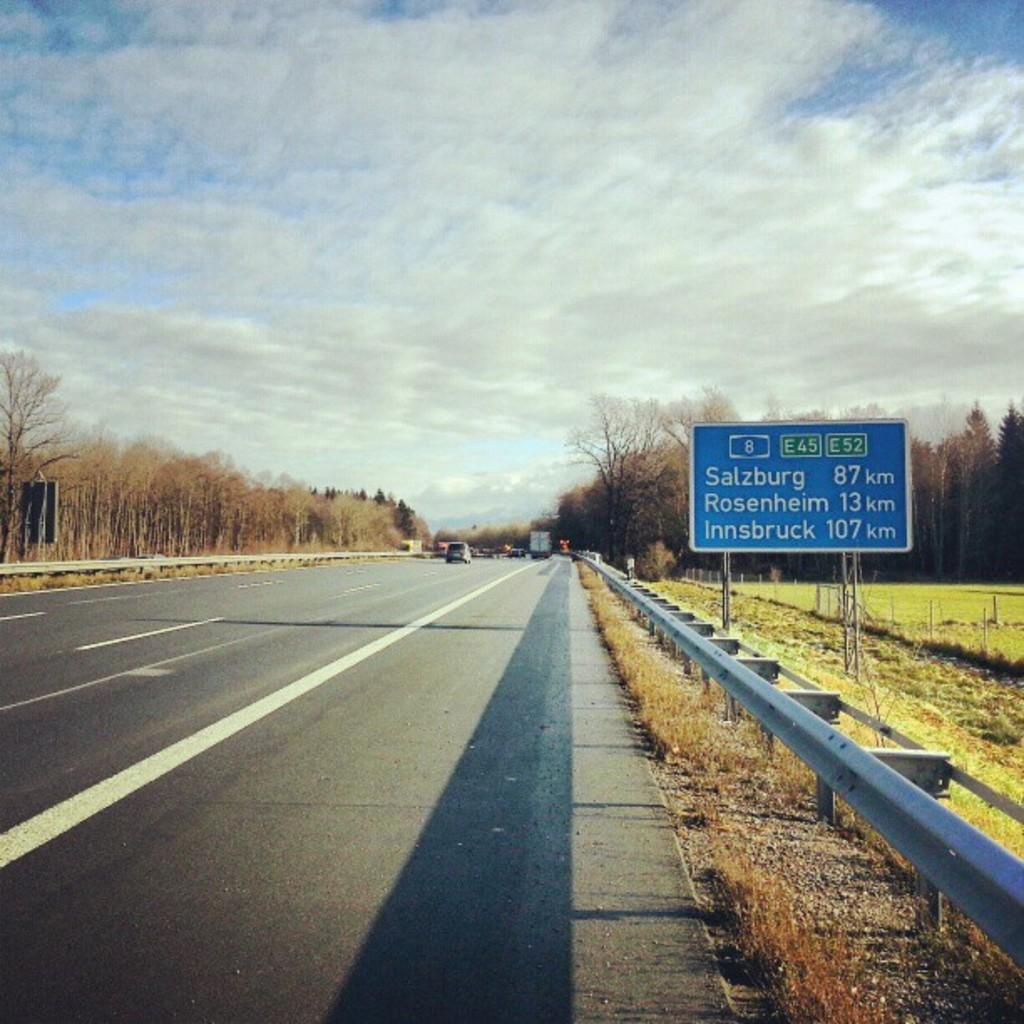What is the main object in the image? There is a blue color board in the image. What is written on the board? Something is written on the board. What type of vegetation can be seen in the image? There are trees in the image. What type of fencing is present in the image? There is iron fencing in the image. What can be seen on the road in the image? There are vehicles on the road in the image. What colors are visible in the sky in the image? The sky is in white and blue color. Can you see a plough being used in the image? No, there is no plough present in the image. Is there a stream visible in the image? No, there is no stream visible in the image. 